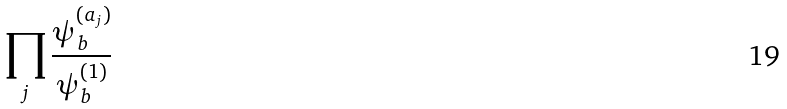Convert formula to latex. <formula><loc_0><loc_0><loc_500><loc_500>\prod _ { j } { \frac { \psi _ { b } ^ { ( a _ { j } ) } } { \psi _ { b } ^ { ( 1 ) } } }</formula> 